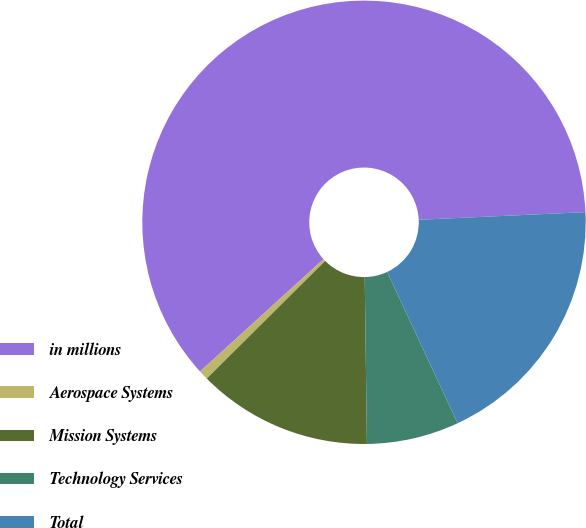<chart> <loc_0><loc_0><loc_500><loc_500><pie_chart><fcel>in millions<fcel>Aerospace Systems<fcel>Mission Systems<fcel>Technology Services<fcel>Total<nl><fcel>61.02%<fcel>0.7%<fcel>12.76%<fcel>6.73%<fcel>18.79%<nl></chart> 